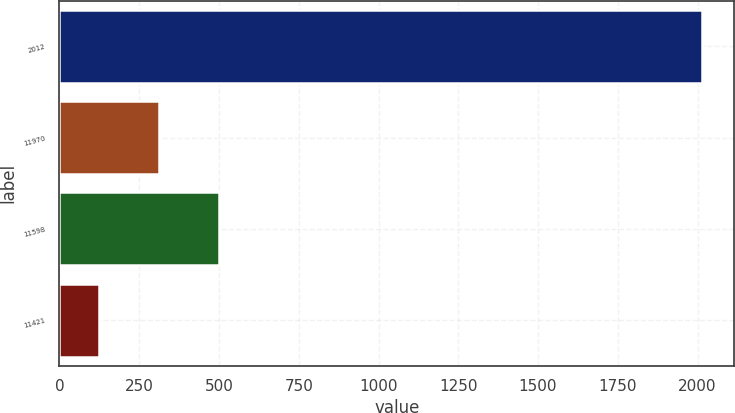<chart> <loc_0><loc_0><loc_500><loc_500><bar_chart><fcel>2012<fcel>11970<fcel>11598<fcel>11421<nl><fcel>2014<fcel>312.06<fcel>501.16<fcel>122.96<nl></chart> 